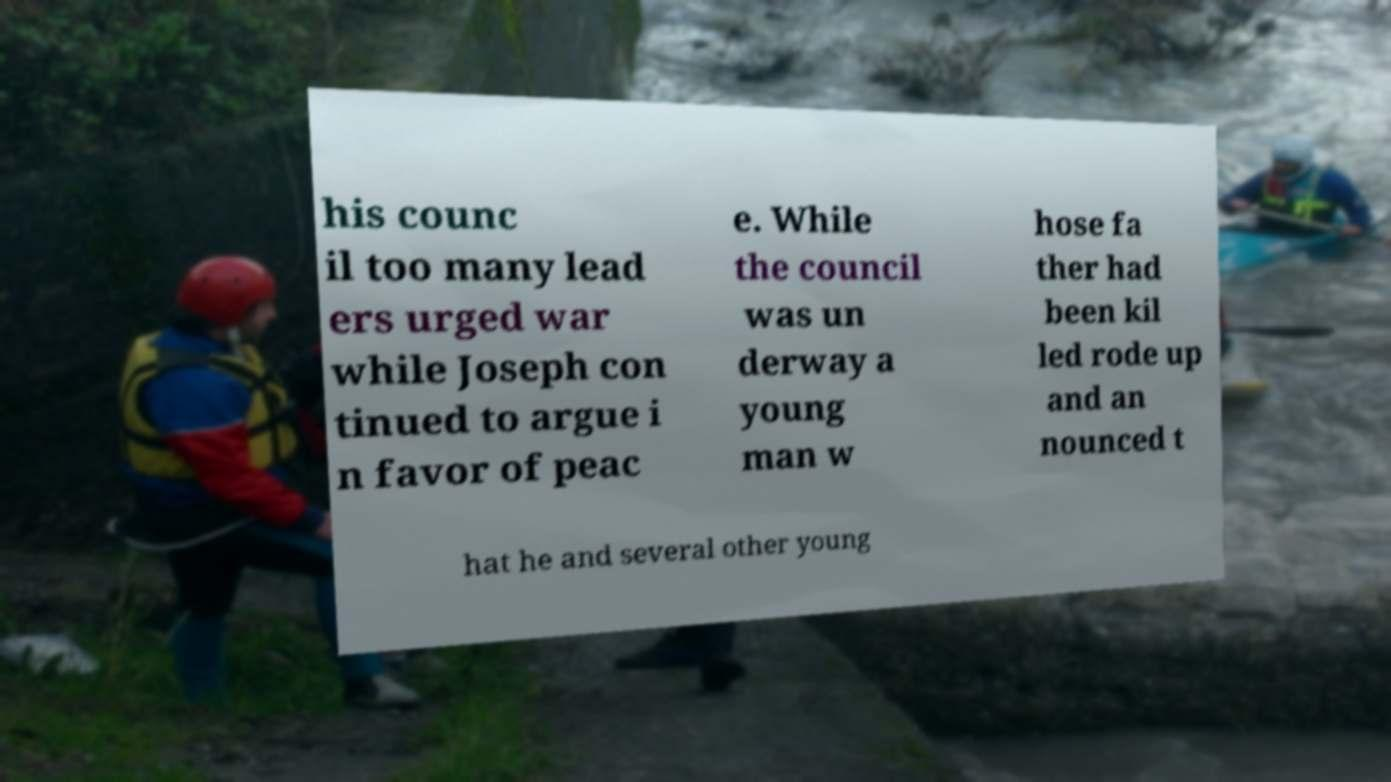There's text embedded in this image that I need extracted. Can you transcribe it verbatim? his counc il too many lead ers urged war while Joseph con tinued to argue i n favor of peac e. While the council was un derway a young man w hose fa ther had been kil led rode up and an nounced t hat he and several other young 